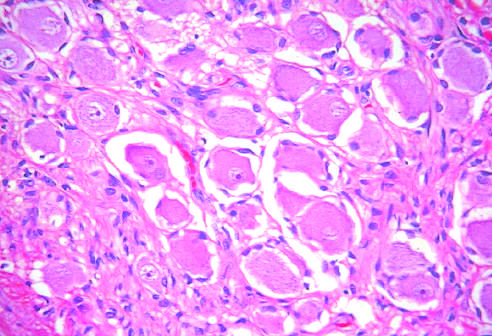do testicular teratomas contain mature cells from endodermal, mesodermal, and ectodermal lines?
Answer the question using a single word or phrase. Yes 